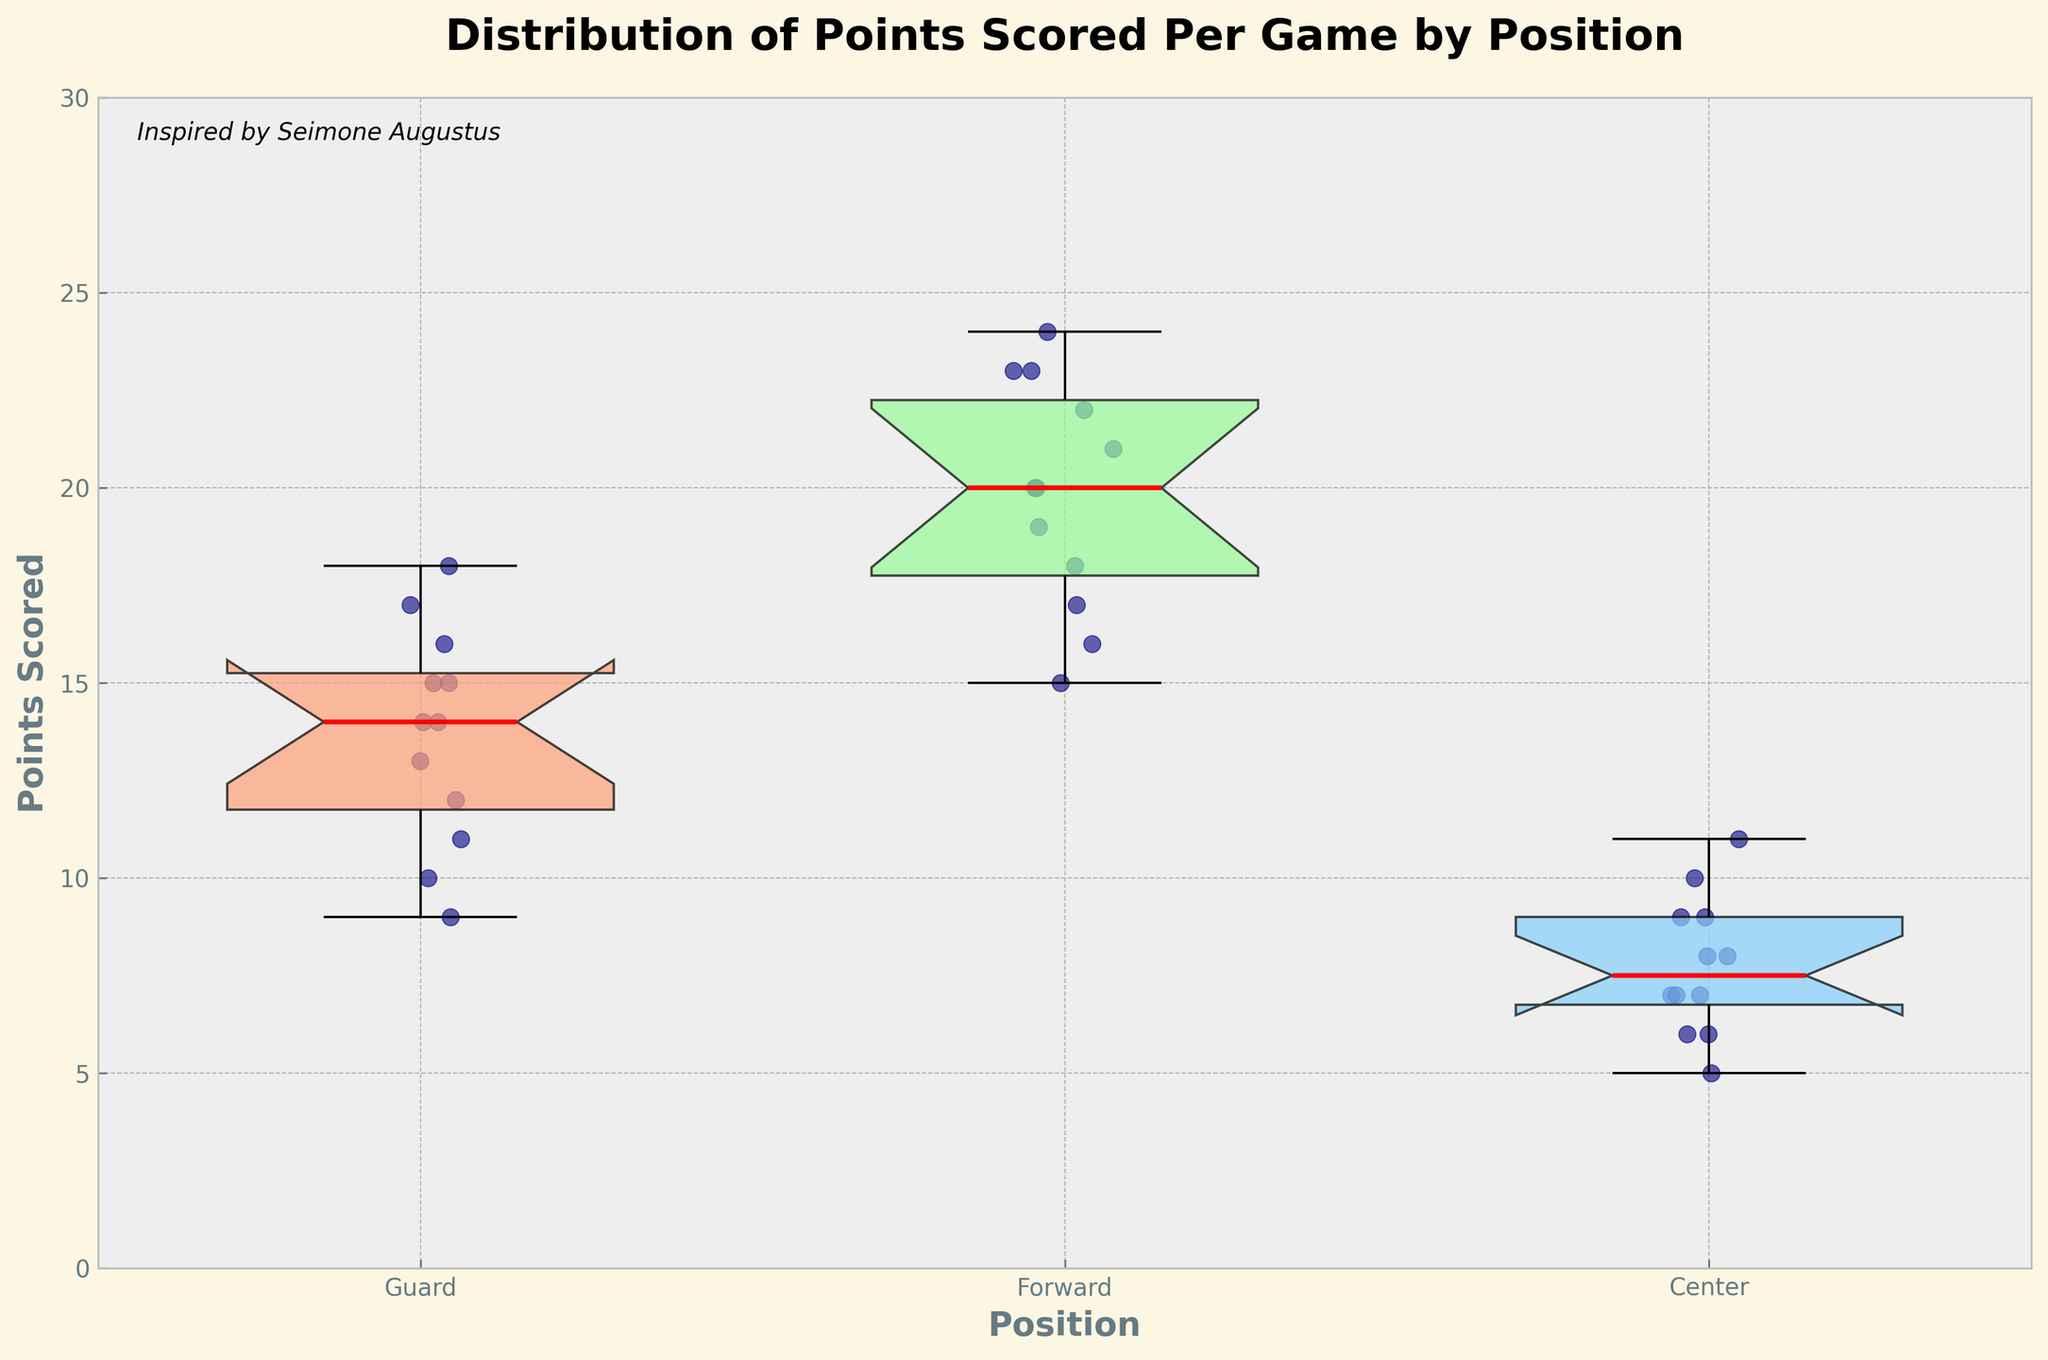What is the title of the plot? The title of the plot is written at the top of the figure and is titled "Distribution of Points Scored Per Game by Position".
Answer: Distribution of Points Scored Per Game by Position How many different positions are compared in the plot? The figure has three separate box plots which correspond to the three different positions, as indicated by the labels on the x-axis: Guard, Forward, and Center.
Answer: 3 What is the range of points scored by the Forwards? The range for the Forwards can be determined by looking at the bottom and top "whiskers" of the box plot for Forwards. The lowest value is at 15 (bottom whisker) and the highest value is at 24 (top whisker). So the range is 24 - 15 = 9.
Answer: 9 Which position shows the highest median points scored? To determine this, find the red line within each box plot, which represents the median. The median for Guards is around 14, for Forwards is around 22, and for Centers is around 8. Thus, the Forwards have the highest median.
Answer: Forwards Which position has the most consistent scoring as indicated by the interquartile range (IQR)? The IQR is represented by the height of the box in each box plot. The smaller the box, the more consistent the data. Comparing the boxes, Guards have the narrowest box indicating the smallest IQR. They show more consistent scoring.
Answer: Guards How many outliers are there in the Guard's points scored? Outliers are represented as individual points beyond the whiskers of the box plot. From the plot, Guards do not show any points outside the whiskers, hence there are no visible outliers for this position.
Answer: 0 What is the upper fence (upper bound) for the points scored by Centers? The upper fence is indicated by the top "whisker" of the box plot for Centers. This whisker extends up to 11 points. Thus, the upper fence for Centers is 11 points.
Answer: 11 Which position has the wider spread of data, Guards or Centers? The spread of data can be estimated by the range from the bottom whisker to the top whisker. For Guards, the range is from 9 to 18, and for Centers, it is from 5 to 11. The range for Guards is 18 - 9 = 9 and for Centers is 11 - 5 = 6. Therefore, Guards have a wider spread.
Answer: Guards 